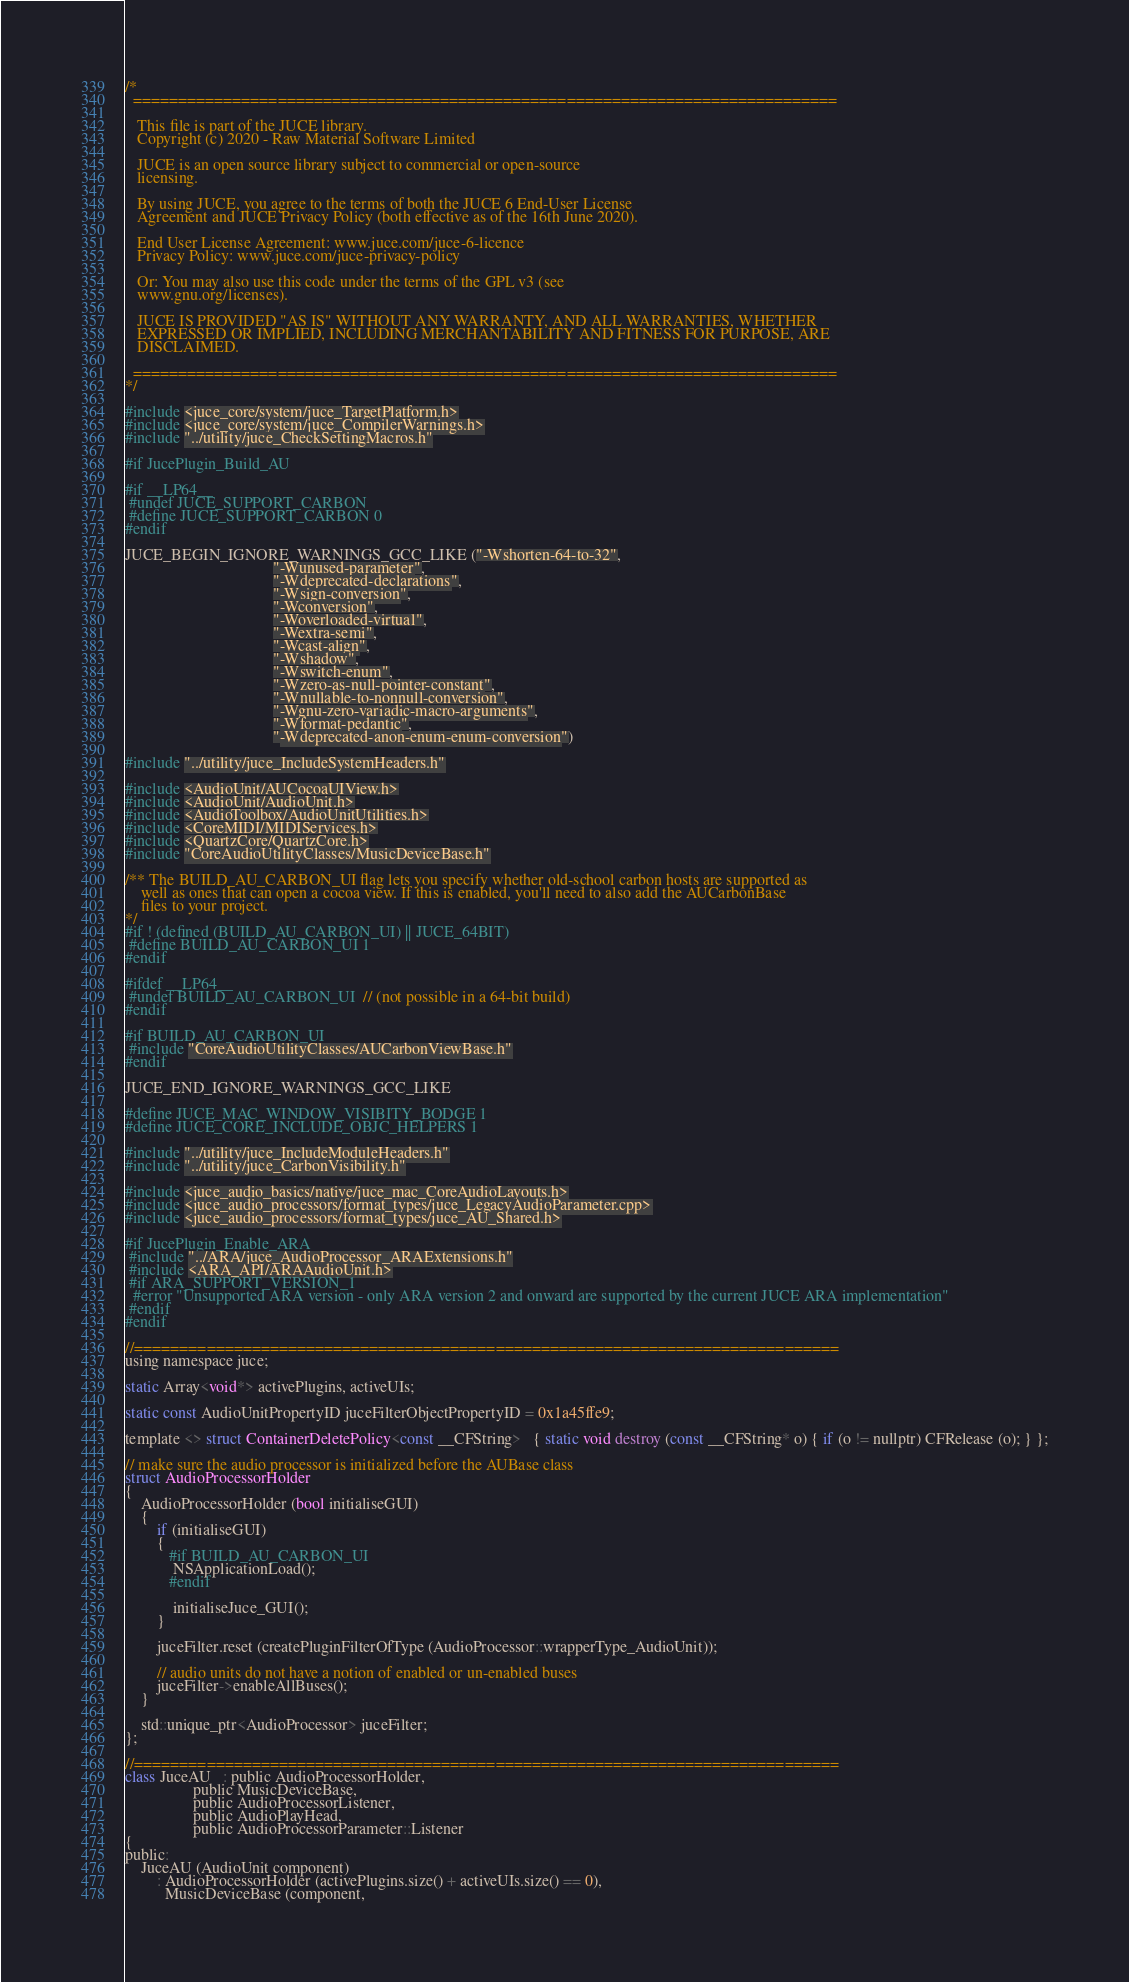Convert code to text. <code><loc_0><loc_0><loc_500><loc_500><_ObjectiveC_>/*
  ==============================================================================

   This file is part of the JUCE library.
   Copyright (c) 2020 - Raw Material Software Limited

   JUCE is an open source library subject to commercial or open-source
   licensing.

   By using JUCE, you agree to the terms of both the JUCE 6 End-User License
   Agreement and JUCE Privacy Policy (both effective as of the 16th June 2020).

   End User License Agreement: www.juce.com/juce-6-licence
   Privacy Policy: www.juce.com/juce-privacy-policy

   Or: You may also use this code under the terms of the GPL v3 (see
   www.gnu.org/licenses).

   JUCE IS PROVIDED "AS IS" WITHOUT ANY WARRANTY, AND ALL WARRANTIES, WHETHER
   EXPRESSED OR IMPLIED, INCLUDING MERCHANTABILITY AND FITNESS FOR PURPOSE, ARE
   DISCLAIMED.

  ==============================================================================
*/

#include <juce_core/system/juce_TargetPlatform.h>
#include <juce_core/system/juce_CompilerWarnings.h>
#include "../utility/juce_CheckSettingMacros.h"

#if JucePlugin_Build_AU

#if __LP64__
 #undef JUCE_SUPPORT_CARBON
 #define JUCE_SUPPORT_CARBON 0
#endif

JUCE_BEGIN_IGNORE_WARNINGS_GCC_LIKE ("-Wshorten-64-to-32",
                                     "-Wunused-parameter",
                                     "-Wdeprecated-declarations",
                                     "-Wsign-conversion",
                                     "-Wconversion",
                                     "-Woverloaded-virtual",
                                     "-Wextra-semi",
                                     "-Wcast-align",
                                     "-Wshadow",
                                     "-Wswitch-enum",
                                     "-Wzero-as-null-pointer-constant",
                                     "-Wnullable-to-nonnull-conversion",
                                     "-Wgnu-zero-variadic-macro-arguments",
                                     "-Wformat-pedantic",
                                     "-Wdeprecated-anon-enum-enum-conversion")

#include "../utility/juce_IncludeSystemHeaders.h"

#include <AudioUnit/AUCocoaUIView.h>
#include <AudioUnit/AudioUnit.h>
#include <AudioToolbox/AudioUnitUtilities.h>
#include <CoreMIDI/MIDIServices.h>
#include <QuartzCore/QuartzCore.h>
#include "CoreAudioUtilityClasses/MusicDeviceBase.h"

/** The BUILD_AU_CARBON_UI flag lets you specify whether old-school carbon hosts are supported as
    well as ones that can open a cocoa view. If this is enabled, you'll need to also add the AUCarbonBase
    files to your project.
*/
#if ! (defined (BUILD_AU_CARBON_UI) || JUCE_64BIT)
 #define BUILD_AU_CARBON_UI 1
#endif

#ifdef __LP64__
 #undef BUILD_AU_CARBON_UI  // (not possible in a 64-bit build)
#endif

#if BUILD_AU_CARBON_UI
 #include "CoreAudioUtilityClasses/AUCarbonViewBase.h"
#endif

JUCE_END_IGNORE_WARNINGS_GCC_LIKE

#define JUCE_MAC_WINDOW_VISIBITY_BODGE 1
#define JUCE_CORE_INCLUDE_OBJC_HELPERS 1

#include "../utility/juce_IncludeModuleHeaders.h"
#include "../utility/juce_CarbonVisibility.h"

#include <juce_audio_basics/native/juce_mac_CoreAudioLayouts.h>
#include <juce_audio_processors/format_types/juce_LegacyAudioParameter.cpp>
#include <juce_audio_processors/format_types/juce_AU_Shared.h>

#if JucePlugin_Enable_ARA
 #include "../ARA/juce_AudioProcessor_ARAExtensions.h"
 #include <ARA_API/ARAAudioUnit.h>
 #if ARA_SUPPORT_VERSION_1
  #error "Unsupported ARA version - only ARA version 2 and onward are supported by the current JUCE ARA implementation"
 #endif
#endif

//==============================================================================
using namespace juce;

static Array<void*> activePlugins, activeUIs;

static const AudioUnitPropertyID juceFilterObjectPropertyID = 0x1a45ffe9;

template <> struct ContainerDeletePolicy<const __CFString>   { static void destroy (const __CFString* o) { if (o != nullptr) CFRelease (o); } };

// make sure the audio processor is initialized before the AUBase class
struct AudioProcessorHolder
{
    AudioProcessorHolder (bool initialiseGUI)
    {
        if (initialiseGUI)
        {
           #if BUILD_AU_CARBON_UI
            NSApplicationLoad();
           #endif

            initialiseJuce_GUI();
        }

        juceFilter.reset (createPluginFilterOfType (AudioProcessor::wrapperType_AudioUnit));

        // audio units do not have a notion of enabled or un-enabled buses
        juceFilter->enableAllBuses();
    }

    std::unique_ptr<AudioProcessor> juceFilter;
};

//==============================================================================
class JuceAU   : public AudioProcessorHolder,
                 public MusicDeviceBase,
                 public AudioProcessorListener,
                 public AudioPlayHead,
                 public AudioProcessorParameter::Listener
{
public:
    JuceAU (AudioUnit component)
        : AudioProcessorHolder (activePlugins.size() + activeUIs.size() == 0),
          MusicDeviceBase (component,</code> 